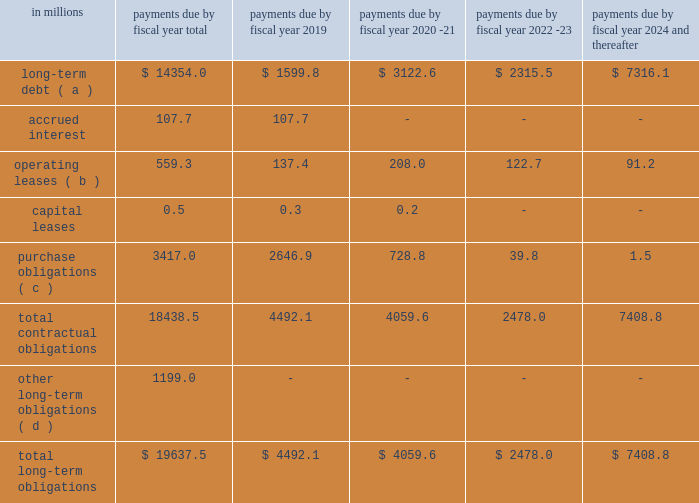Obligations of non-consolidated affiliates , mainly cpw .
In addition , off-balance sheet arrangements are generally limited to the future payments under non-cancelable operating leases , which totaled $ 559 million as of may 27 , as of may 27 , 2018 , we had invested in five variable interest entities ( vies ) .
None of our vies are material to our results of operations , financial condition , or liquidity as of and for the fiscal year ended may 27 , 2018 .
Our defined benefit plans in the united states are subject to the requirements of the pension protection act ( ppa ) .
In the future , the ppa may require us to make additional contributions to our domestic plans .
We do not expect to be required to make any contributions in fiscal 2019 .
The table summarizes our future estimated cash payments under existing contractual obligations , including payments due by period: .
( a ) amounts represent the expected cash payments of our long-term debt and do not include $ 0.5 million for capital leases or $ 85.7 million for net unamortized debt issuance costs , premiums and discounts , and fair value adjustments .
( b ) operating leases represents the minimum rental commitments under non-cancelable operating leases .
( c ) the majority of the purchase obligations represent commitments for raw material and packaging to be utilized in the normal course of business and for consumer marketing spending commitments that support our brands .
For purposes of this table , arrangements are considered purchase obligations if a contract specifies all significant terms , including fixed or minimum quantities to be purchased , a pricing structure , and approximate timing of the transaction .
Most arrangements are cancelable without a significant penalty and with short notice ( usually 30 days ) .
Any amounts reflected on the consolidated balance sheets as accounts payable and accrued liabilities are excluded from the table above .
( d ) the fair value of our foreign exchange , equity , commodity , and grain derivative contracts with a payable position to the counterparty was $ 16 million as of may 27 , 2018 , based on fair market values as of that date .
Future changes in market values will impact the amount of cash ultimately paid or received to settle those instruments in the future .
Other long-term obligations mainly consist of liabilities for accrued compensation and benefits , including the underfunded status of certain of our defined benefit pension , other postretirement benefit , and postemployment benefit plans , and miscellaneous liabilities .
We expect to pay $ 20 million of benefits from our unfunded postemployment benefit plans and $ 18 million of deferred compensation in fiscal 2019 .
We are unable to reliably estimate the amount of these payments beyond fiscal 2019 .
As of may 27 , 2018 , our total liability for uncertain tax positions and accrued interest and penalties was $ 223.6 million .
Significant accounting estimates for a complete description of our significant accounting policies , please see note 2 to the consolidated financial statements in item 8 of this report .
Our significant accounting estimates are those that have a meaningful impact .
What portion of the total long-term obligations are due by the fiscal year 2019? 
Computations: (4492.1 / 19637.5)
Answer: 0.22875. 